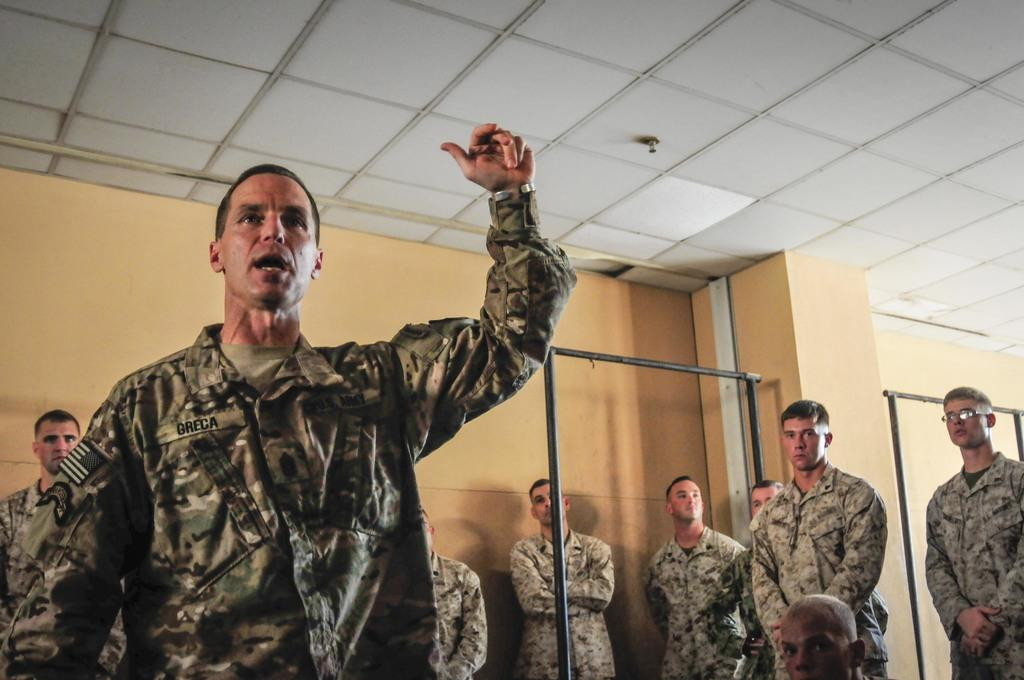What can be seen in the image? There is a group of people in the image. What are the people wearing? The people are wearing military uniforms. What objects can be seen in the background of the image? There is an iron rod and a wall in the background of the image. What type of game is being played by the people in the image? There is no game being played in the image; the people are wearing military uniforms, which suggests they might be part of a military unit or participating in a military-related activity. 